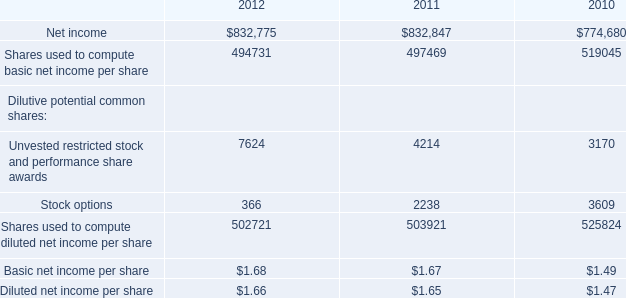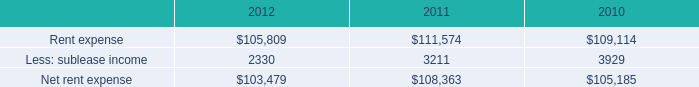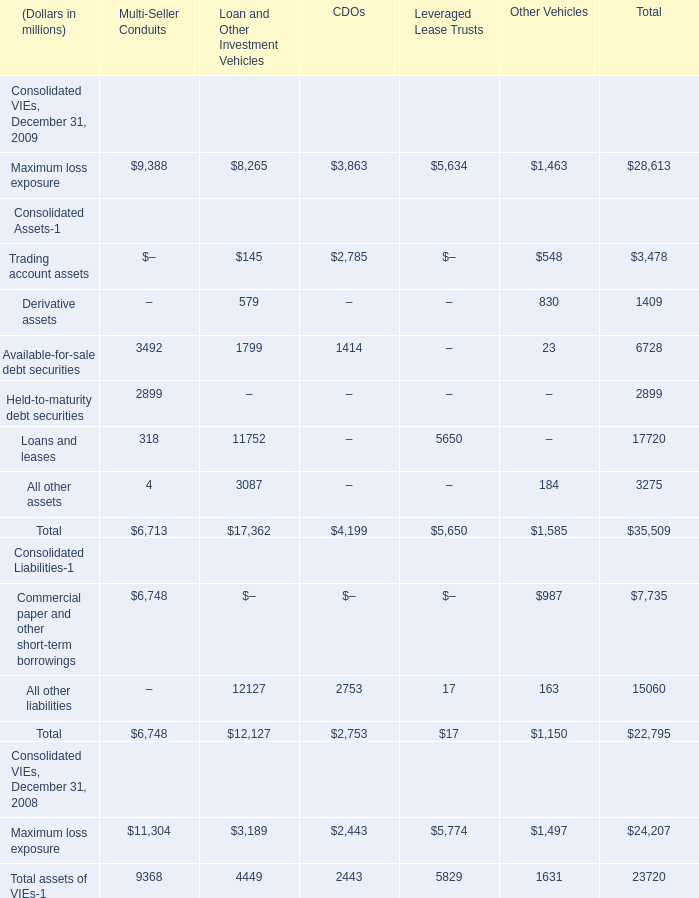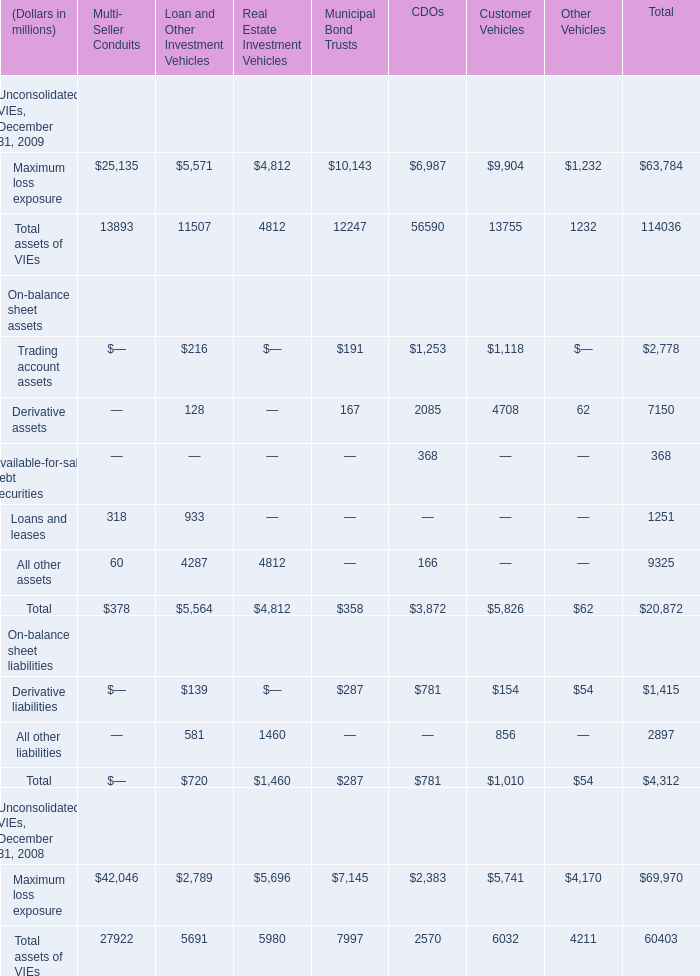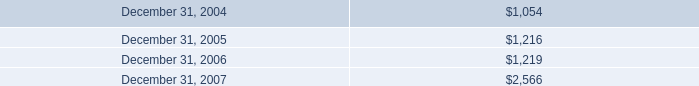Which year is Maximum loss exposure for Multi- Seller Conduits greater than 26000 ? 
Answer: 2008. 